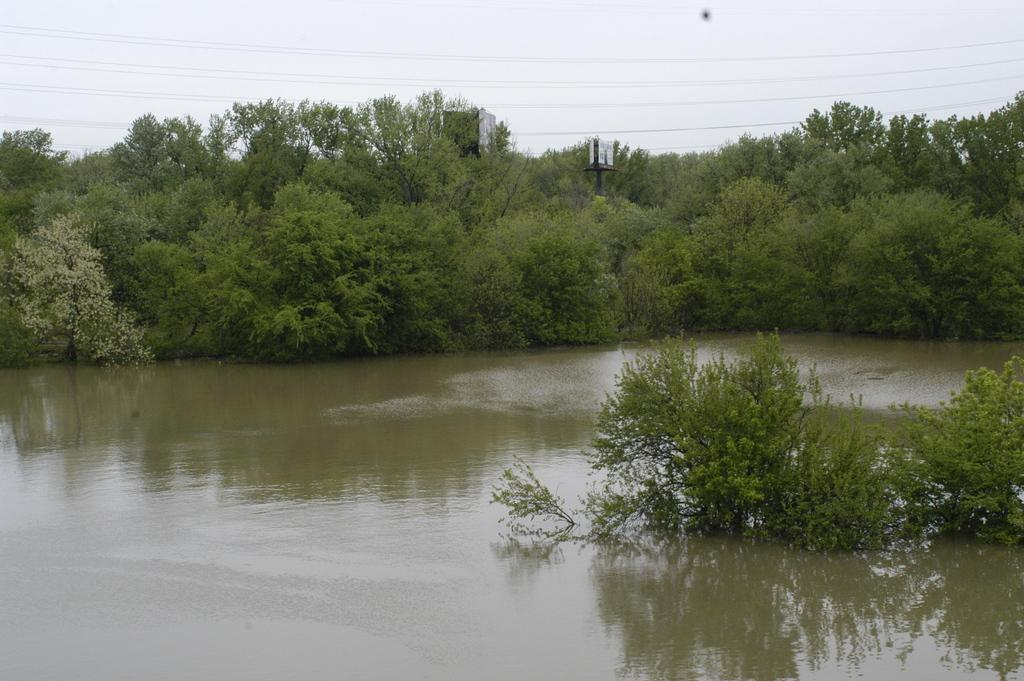What is the primary element visible in the image? There is water in the image. What type of vegetation can be seen in the image? There are green trees in the image. What is visible at the top of the image? The sky is visible at the top of the image. Can you tell me how many bridges are present in the image? There are no bridges visible in the image; it features water, green trees, and the sky. What type of health benefits can be gained from the water in the image? The image does not provide information about the health benefits of the water; it only shows the presence of water, green trees, and the sky. 